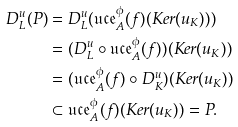Convert formula to latex. <formula><loc_0><loc_0><loc_500><loc_500>D _ { L } ^ { u } ( P ) & = D _ { L } ^ { u } ( \mathfrak { u c e } ^ { \phi } _ { A } ( f ) ( K e r ( u _ { K } ) ) ) \\ & = ( D _ { L } ^ { u } \circ \mathfrak { u c e } ^ { \phi } _ { A } ( f ) ) ( K e r ( u _ { K } ) ) \\ & = ( \mathfrak { u c e } ^ { \phi } _ { A } ( f ) \circ D _ { K } ^ { u } ) ( K e r ( u _ { K } ) ) \\ & \subset \mathfrak { u c e } ^ { \phi } _ { A } ( f ) ( K e r ( u _ { K } ) ) = P .</formula> 